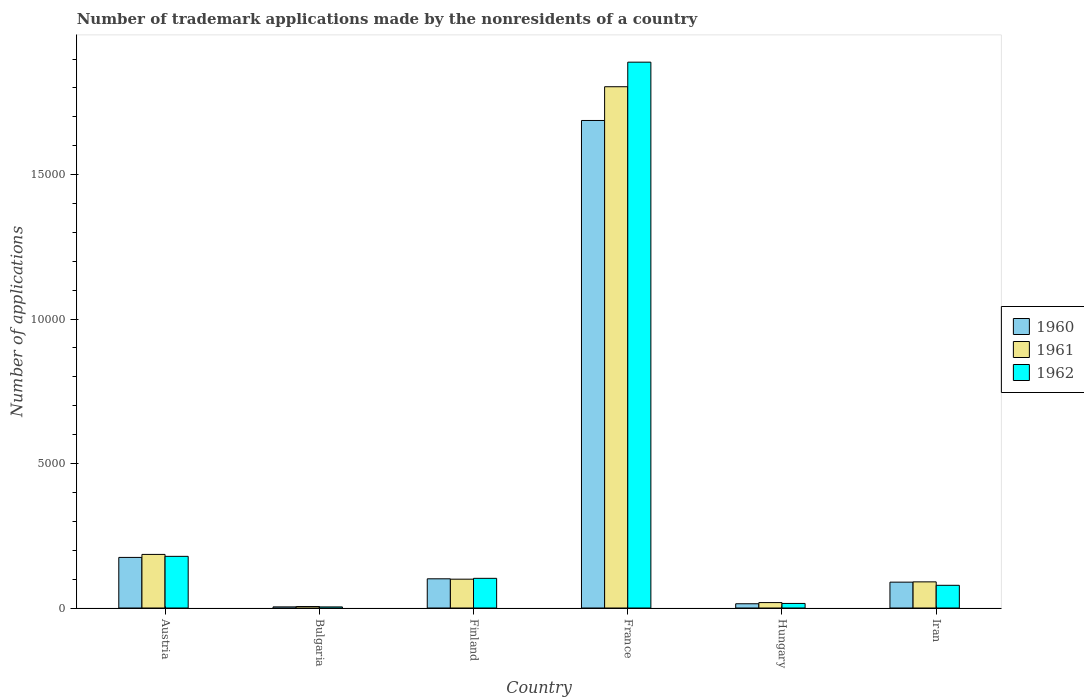How many groups of bars are there?
Offer a terse response. 6. Are the number of bars per tick equal to the number of legend labels?
Give a very brief answer. Yes. Are the number of bars on each tick of the X-axis equal?
Offer a terse response. Yes. What is the label of the 6th group of bars from the left?
Make the answer very short. Iran. In how many cases, is the number of bars for a given country not equal to the number of legend labels?
Offer a terse response. 0. What is the number of trademark applications made by the nonresidents in 1962 in Hungary?
Make the answer very short. 158. Across all countries, what is the maximum number of trademark applications made by the nonresidents in 1961?
Give a very brief answer. 1.80e+04. Across all countries, what is the minimum number of trademark applications made by the nonresidents in 1962?
Provide a short and direct response. 38. What is the total number of trademark applications made by the nonresidents in 1961 in the graph?
Your answer should be compact. 2.20e+04. What is the difference between the number of trademark applications made by the nonresidents in 1962 in Austria and that in France?
Offer a very short reply. -1.71e+04. What is the difference between the number of trademark applications made by the nonresidents in 1962 in Iran and the number of trademark applications made by the nonresidents in 1961 in Austria?
Give a very brief answer. -1069. What is the average number of trademark applications made by the nonresidents in 1960 per country?
Give a very brief answer. 3452.83. What is the difference between the number of trademark applications made by the nonresidents of/in 1961 and number of trademark applications made by the nonresidents of/in 1962 in Hungary?
Offer a terse response. 30. In how many countries, is the number of trademark applications made by the nonresidents in 1960 greater than 18000?
Provide a short and direct response. 0. What is the ratio of the number of trademark applications made by the nonresidents in 1962 in Austria to that in Finland?
Your response must be concise. 1.74. Is the number of trademark applications made by the nonresidents in 1961 in Finland less than that in France?
Give a very brief answer. Yes. Is the difference between the number of trademark applications made by the nonresidents in 1961 in Austria and Bulgaria greater than the difference between the number of trademark applications made by the nonresidents in 1962 in Austria and Bulgaria?
Give a very brief answer. Yes. What is the difference between the highest and the second highest number of trademark applications made by the nonresidents in 1960?
Offer a very short reply. 1.59e+04. What is the difference between the highest and the lowest number of trademark applications made by the nonresidents in 1961?
Keep it short and to the point. 1.80e+04. What does the 2nd bar from the left in Iran represents?
Give a very brief answer. 1961. What does the 2nd bar from the right in Finland represents?
Keep it short and to the point. 1961. Is it the case that in every country, the sum of the number of trademark applications made by the nonresidents in 1961 and number of trademark applications made by the nonresidents in 1960 is greater than the number of trademark applications made by the nonresidents in 1962?
Keep it short and to the point. Yes. Are the values on the major ticks of Y-axis written in scientific E-notation?
Ensure brevity in your answer.  No. Does the graph contain grids?
Provide a short and direct response. No. Where does the legend appear in the graph?
Ensure brevity in your answer.  Center right. How are the legend labels stacked?
Keep it short and to the point. Vertical. What is the title of the graph?
Make the answer very short. Number of trademark applications made by the nonresidents of a country. Does "1962" appear as one of the legend labels in the graph?
Your response must be concise. Yes. What is the label or title of the X-axis?
Make the answer very short. Country. What is the label or title of the Y-axis?
Offer a terse response. Number of applications. What is the Number of applications of 1960 in Austria?
Offer a very short reply. 1751. What is the Number of applications in 1961 in Austria?
Ensure brevity in your answer.  1855. What is the Number of applications of 1962 in Austria?
Give a very brief answer. 1788. What is the Number of applications of 1960 in Finland?
Ensure brevity in your answer.  1011. What is the Number of applications in 1961 in Finland?
Offer a very short reply. 998. What is the Number of applications of 1962 in Finland?
Provide a succinct answer. 1027. What is the Number of applications of 1960 in France?
Offer a terse response. 1.69e+04. What is the Number of applications in 1961 in France?
Ensure brevity in your answer.  1.80e+04. What is the Number of applications of 1962 in France?
Offer a very short reply. 1.89e+04. What is the Number of applications of 1960 in Hungary?
Offer a very short reply. 147. What is the Number of applications of 1961 in Hungary?
Your answer should be very brief. 188. What is the Number of applications in 1962 in Hungary?
Your response must be concise. 158. What is the Number of applications in 1960 in Iran?
Offer a very short reply. 895. What is the Number of applications in 1961 in Iran?
Make the answer very short. 905. What is the Number of applications in 1962 in Iran?
Your answer should be very brief. 786. Across all countries, what is the maximum Number of applications of 1960?
Make the answer very short. 1.69e+04. Across all countries, what is the maximum Number of applications in 1961?
Give a very brief answer. 1.80e+04. Across all countries, what is the maximum Number of applications of 1962?
Your answer should be very brief. 1.89e+04. Across all countries, what is the minimum Number of applications of 1960?
Make the answer very short. 39. Across all countries, what is the minimum Number of applications of 1961?
Your response must be concise. 51. Across all countries, what is the minimum Number of applications in 1962?
Offer a very short reply. 38. What is the total Number of applications in 1960 in the graph?
Keep it short and to the point. 2.07e+04. What is the total Number of applications of 1961 in the graph?
Offer a very short reply. 2.20e+04. What is the total Number of applications of 1962 in the graph?
Your answer should be compact. 2.27e+04. What is the difference between the Number of applications in 1960 in Austria and that in Bulgaria?
Your answer should be compact. 1712. What is the difference between the Number of applications of 1961 in Austria and that in Bulgaria?
Provide a short and direct response. 1804. What is the difference between the Number of applications of 1962 in Austria and that in Bulgaria?
Your answer should be compact. 1750. What is the difference between the Number of applications in 1960 in Austria and that in Finland?
Make the answer very short. 740. What is the difference between the Number of applications in 1961 in Austria and that in Finland?
Your answer should be compact. 857. What is the difference between the Number of applications in 1962 in Austria and that in Finland?
Provide a succinct answer. 761. What is the difference between the Number of applications of 1960 in Austria and that in France?
Ensure brevity in your answer.  -1.51e+04. What is the difference between the Number of applications in 1961 in Austria and that in France?
Give a very brief answer. -1.62e+04. What is the difference between the Number of applications of 1962 in Austria and that in France?
Provide a short and direct response. -1.71e+04. What is the difference between the Number of applications in 1960 in Austria and that in Hungary?
Ensure brevity in your answer.  1604. What is the difference between the Number of applications in 1961 in Austria and that in Hungary?
Provide a short and direct response. 1667. What is the difference between the Number of applications of 1962 in Austria and that in Hungary?
Give a very brief answer. 1630. What is the difference between the Number of applications in 1960 in Austria and that in Iran?
Make the answer very short. 856. What is the difference between the Number of applications of 1961 in Austria and that in Iran?
Provide a succinct answer. 950. What is the difference between the Number of applications of 1962 in Austria and that in Iran?
Keep it short and to the point. 1002. What is the difference between the Number of applications of 1960 in Bulgaria and that in Finland?
Your response must be concise. -972. What is the difference between the Number of applications of 1961 in Bulgaria and that in Finland?
Your answer should be very brief. -947. What is the difference between the Number of applications of 1962 in Bulgaria and that in Finland?
Provide a succinct answer. -989. What is the difference between the Number of applications of 1960 in Bulgaria and that in France?
Your answer should be very brief. -1.68e+04. What is the difference between the Number of applications of 1961 in Bulgaria and that in France?
Your answer should be very brief. -1.80e+04. What is the difference between the Number of applications of 1962 in Bulgaria and that in France?
Your answer should be compact. -1.89e+04. What is the difference between the Number of applications of 1960 in Bulgaria and that in Hungary?
Provide a short and direct response. -108. What is the difference between the Number of applications of 1961 in Bulgaria and that in Hungary?
Ensure brevity in your answer.  -137. What is the difference between the Number of applications of 1962 in Bulgaria and that in Hungary?
Keep it short and to the point. -120. What is the difference between the Number of applications of 1960 in Bulgaria and that in Iran?
Provide a succinct answer. -856. What is the difference between the Number of applications in 1961 in Bulgaria and that in Iran?
Keep it short and to the point. -854. What is the difference between the Number of applications of 1962 in Bulgaria and that in Iran?
Give a very brief answer. -748. What is the difference between the Number of applications in 1960 in Finland and that in France?
Your answer should be compact. -1.59e+04. What is the difference between the Number of applications of 1961 in Finland and that in France?
Your answer should be very brief. -1.70e+04. What is the difference between the Number of applications in 1962 in Finland and that in France?
Offer a very short reply. -1.79e+04. What is the difference between the Number of applications of 1960 in Finland and that in Hungary?
Keep it short and to the point. 864. What is the difference between the Number of applications in 1961 in Finland and that in Hungary?
Your response must be concise. 810. What is the difference between the Number of applications in 1962 in Finland and that in Hungary?
Offer a very short reply. 869. What is the difference between the Number of applications in 1960 in Finland and that in Iran?
Your response must be concise. 116. What is the difference between the Number of applications in 1961 in Finland and that in Iran?
Keep it short and to the point. 93. What is the difference between the Number of applications of 1962 in Finland and that in Iran?
Your answer should be very brief. 241. What is the difference between the Number of applications of 1960 in France and that in Hungary?
Your response must be concise. 1.67e+04. What is the difference between the Number of applications in 1961 in France and that in Hungary?
Provide a short and direct response. 1.79e+04. What is the difference between the Number of applications in 1962 in France and that in Hungary?
Your answer should be very brief. 1.87e+04. What is the difference between the Number of applications of 1960 in France and that in Iran?
Offer a very short reply. 1.60e+04. What is the difference between the Number of applications in 1961 in France and that in Iran?
Your response must be concise. 1.71e+04. What is the difference between the Number of applications of 1962 in France and that in Iran?
Provide a succinct answer. 1.81e+04. What is the difference between the Number of applications of 1960 in Hungary and that in Iran?
Your answer should be compact. -748. What is the difference between the Number of applications in 1961 in Hungary and that in Iran?
Keep it short and to the point. -717. What is the difference between the Number of applications in 1962 in Hungary and that in Iran?
Ensure brevity in your answer.  -628. What is the difference between the Number of applications in 1960 in Austria and the Number of applications in 1961 in Bulgaria?
Keep it short and to the point. 1700. What is the difference between the Number of applications in 1960 in Austria and the Number of applications in 1962 in Bulgaria?
Keep it short and to the point. 1713. What is the difference between the Number of applications of 1961 in Austria and the Number of applications of 1962 in Bulgaria?
Your response must be concise. 1817. What is the difference between the Number of applications of 1960 in Austria and the Number of applications of 1961 in Finland?
Make the answer very short. 753. What is the difference between the Number of applications of 1960 in Austria and the Number of applications of 1962 in Finland?
Your answer should be compact. 724. What is the difference between the Number of applications of 1961 in Austria and the Number of applications of 1962 in Finland?
Give a very brief answer. 828. What is the difference between the Number of applications in 1960 in Austria and the Number of applications in 1961 in France?
Offer a terse response. -1.63e+04. What is the difference between the Number of applications of 1960 in Austria and the Number of applications of 1962 in France?
Make the answer very short. -1.71e+04. What is the difference between the Number of applications of 1961 in Austria and the Number of applications of 1962 in France?
Offer a very short reply. -1.70e+04. What is the difference between the Number of applications in 1960 in Austria and the Number of applications in 1961 in Hungary?
Your response must be concise. 1563. What is the difference between the Number of applications of 1960 in Austria and the Number of applications of 1962 in Hungary?
Provide a short and direct response. 1593. What is the difference between the Number of applications of 1961 in Austria and the Number of applications of 1962 in Hungary?
Make the answer very short. 1697. What is the difference between the Number of applications in 1960 in Austria and the Number of applications in 1961 in Iran?
Provide a short and direct response. 846. What is the difference between the Number of applications in 1960 in Austria and the Number of applications in 1962 in Iran?
Offer a very short reply. 965. What is the difference between the Number of applications in 1961 in Austria and the Number of applications in 1962 in Iran?
Provide a succinct answer. 1069. What is the difference between the Number of applications of 1960 in Bulgaria and the Number of applications of 1961 in Finland?
Ensure brevity in your answer.  -959. What is the difference between the Number of applications in 1960 in Bulgaria and the Number of applications in 1962 in Finland?
Your answer should be compact. -988. What is the difference between the Number of applications in 1961 in Bulgaria and the Number of applications in 1962 in Finland?
Offer a very short reply. -976. What is the difference between the Number of applications of 1960 in Bulgaria and the Number of applications of 1961 in France?
Offer a terse response. -1.80e+04. What is the difference between the Number of applications in 1960 in Bulgaria and the Number of applications in 1962 in France?
Provide a succinct answer. -1.89e+04. What is the difference between the Number of applications in 1961 in Bulgaria and the Number of applications in 1962 in France?
Your response must be concise. -1.88e+04. What is the difference between the Number of applications in 1960 in Bulgaria and the Number of applications in 1961 in Hungary?
Keep it short and to the point. -149. What is the difference between the Number of applications in 1960 in Bulgaria and the Number of applications in 1962 in Hungary?
Provide a succinct answer. -119. What is the difference between the Number of applications of 1961 in Bulgaria and the Number of applications of 1962 in Hungary?
Your response must be concise. -107. What is the difference between the Number of applications in 1960 in Bulgaria and the Number of applications in 1961 in Iran?
Your answer should be compact. -866. What is the difference between the Number of applications in 1960 in Bulgaria and the Number of applications in 1962 in Iran?
Provide a succinct answer. -747. What is the difference between the Number of applications of 1961 in Bulgaria and the Number of applications of 1962 in Iran?
Offer a very short reply. -735. What is the difference between the Number of applications of 1960 in Finland and the Number of applications of 1961 in France?
Keep it short and to the point. -1.70e+04. What is the difference between the Number of applications of 1960 in Finland and the Number of applications of 1962 in France?
Keep it short and to the point. -1.79e+04. What is the difference between the Number of applications in 1961 in Finland and the Number of applications in 1962 in France?
Offer a very short reply. -1.79e+04. What is the difference between the Number of applications of 1960 in Finland and the Number of applications of 1961 in Hungary?
Your response must be concise. 823. What is the difference between the Number of applications in 1960 in Finland and the Number of applications in 1962 in Hungary?
Your response must be concise. 853. What is the difference between the Number of applications of 1961 in Finland and the Number of applications of 1962 in Hungary?
Keep it short and to the point. 840. What is the difference between the Number of applications of 1960 in Finland and the Number of applications of 1961 in Iran?
Provide a short and direct response. 106. What is the difference between the Number of applications in 1960 in Finland and the Number of applications in 1962 in Iran?
Provide a succinct answer. 225. What is the difference between the Number of applications of 1961 in Finland and the Number of applications of 1962 in Iran?
Give a very brief answer. 212. What is the difference between the Number of applications of 1960 in France and the Number of applications of 1961 in Hungary?
Provide a succinct answer. 1.67e+04. What is the difference between the Number of applications of 1960 in France and the Number of applications of 1962 in Hungary?
Make the answer very short. 1.67e+04. What is the difference between the Number of applications of 1961 in France and the Number of applications of 1962 in Hungary?
Offer a terse response. 1.79e+04. What is the difference between the Number of applications of 1960 in France and the Number of applications of 1961 in Iran?
Your answer should be compact. 1.60e+04. What is the difference between the Number of applications of 1960 in France and the Number of applications of 1962 in Iran?
Ensure brevity in your answer.  1.61e+04. What is the difference between the Number of applications in 1961 in France and the Number of applications in 1962 in Iran?
Ensure brevity in your answer.  1.73e+04. What is the difference between the Number of applications of 1960 in Hungary and the Number of applications of 1961 in Iran?
Give a very brief answer. -758. What is the difference between the Number of applications in 1960 in Hungary and the Number of applications in 1962 in Iran?
Provide a succinct answer. -639. What is the difference between the Number of applications of 1961 in Hungary and the Number of applications of 1962 in Iran?
Your response must be concise. -598. What is the average Number of applications of 1960 per country?
Provide a short and direct response. 3452.83. What is the average Number of applications in 1961 per country?
Keep it short and to the point. 3673.17. What is the average Number of applications in 1962 per country?
Your answer should be compact. 3781.5. What is the difference between the Number of applications of 1960 and Number of applications of 1961 in Austria?
Offer a terse response. -104. What is the difference between the Number of applications in 1960 and Number of applications in 1962 in Austria?
Your response must be concise. -37. What is the difference between the Number of applications of 1960 and Number of applications of 1962 in Bulgaria?
Offer a very short reply. 1. What is the difference between the Number of applications in 1960 and Number of applications in 1961 in France?
Keep it short and to the point. -1168. What is the difference between the Number of applications of 1960 and Number of applications of 1962 in France?
Provide a short and direct response. -2018. What is the difference between the Number of applications of 1961 and Number of applications of 1962 in France?
Ensure brevity in your answer.  -850. What is the difference between the Number of applications in 1960 and Number of applications in 1961 in Hungary?
Your answer should be very brief. -41. What is the difference between the Number of applications of 1961 and Number of applications of 1962 in Hungary?
Keep it short and to the point. 30. What is the difference between the Number of applications of 1960 and Number of applications of 1961 in Iran?
Provide a short and direct response. -10. What is the difference between the Number of applications in 1960 and Number of applications in 1962 in Iran?
Provide a succinct answer. 109. What is the difference between the Number of applications in 1961 and Number of applications in 1962 in Iran?
Give a very brief answer. 119. What is the ratio of the Number of applications of 1960 in Austria to that in Bulgaria?
Offer a terse response. 44.9. What is the ratio of the Number of applications of 1961 in Austria to that in Bulgaria?
Give a very brief answer. 36.37. What is the ratio of the Number of applications of 1962 in Austria to that in Bulgaria?
Your answer should be compact. 47.05. What is the ratio of the Number of applications of 1960 in Austria to that in Finland?
Offer a very short reply. 1.73. What is the ratio of the Number of applications in 1961 in Austria to that in Finland?
Keep it short and to the point. 1.86. What is the ratio of the Number of applications of 1962 in Austria to that in Finland?
Ensure brevity in your answer.  1.74. What is the ratio of the Number of applications in 1960 in Austria to that in France?
Provide a succinct answer. 0.1. What is the ratio of the Number of applications of 1961 in Austria to that in France?
Give a very brief answer. 0.1. What is the ratio of the Number of applications of 1962 in Austria to that in France?
Your answer should be compact. 0.09. What is the ratio of the Number of applications of 1960 in Austria to that in Hungary?
Make the answer very short. 11.91. What is the ratio of the Number of applications of 1961 in Austria to that in Hungary?
Ensure brevity in your answer.  9.87. What is the ratio of the Number of applications of 1962 in Austria to that in Hungary?
Give a very brief answer. 11.32. What is the ratio of the Number of applications in 1960 in Austria to that in Iran?
Make the answer very short. 1.96. What is the ratio of the Number of applications in 1961 in Austria to that in Iran?
Your response must be concise. 2.05. What is the ratio of the Number of applications in 1962 in Austria to that in Iran?
Your answer should be very brief. 2.27. What is the ratio of the Number of applications of 1960 in Bulgaria to that in Finland?
Provide a succinct answer. 0.04. What is the ratio of the Number of applications in 1961 in Bulgaria to that in Finland?
Offer a very short reply. 0.05. What is the ratio of the Number of applications of 1962 in Bulgaria to that in Finland?
Keep it short and to the point. 0.04. What is the ratio of the Number of applications of 1960 in Bulgaria to that in France?
Offer a terse response. 0. What is the ratio of the Number of applications of 1961 in Bulgaria to that in France?
Keep it short and to the point. 0. What is the ratio of the Number of applications of 1962 in Bulgaria to that in France?
Keep it short and to the point. 0. What is the ratio of the Number of applications of 1960 in Bulgaria to that in Hungary?
Ensure brevity in your answer.  0.27. What is the ratio of the Number of applications in 1961 in Bulgaria to that in Hungary?
Give a very brief answer. 0.27. What is the ratio of the Number of applications in 1962 in Bulgaria to that in Hungary?
Your answer should be very brief. 0.24. What is the ratio of the Number of applications in 1960 in Bulgaria to that in Iran?
Ensure brevity in your answer.  0.04. What is the ratio of the Number of applications of 1961 in Bulgaria to that in Iran?
Provide a short and direct response. 0.06. What is the ratio of the Number of applications in 1962 in Bulgaria to that in Iran?
Your answer should be very brief. 0.05. What is the ratio of the Number of applications of 1960 in Finland to that in France?
Your answer should be very brief. 0.06. What is the ratio of the Number of applications of 1961 in Finland to that in France?
Give a very brief answer. 0.06. What is the ratio of the Number of applications of 1962 in Finland to that in France?
Provide a succinct answer. 0.05. What is the ratio of the Number of applications in 1960 in Finland to that in Hungary?
Give a very brief answer. 6.88. What is the ratio of the Number of applications in 1961 in Finland to that in Hungary?
Offer a very short reply. 5.31. What is the ratio of the Number of applications of 1960 in Finland to that in Iran?
Ensure brevity in your answer.  1.13. What is the ratio of the Number of applications of 1961 in Finland to that in Iran?
Make the answer very short. 1.1. What is the ratio of the Number of applications of 1962 in Finland to that in Iran?
Keep it short and to the point. 1.31. What is the ratio of the Number of applications of 1960 in France to that in Hungary?
Make the answer very short. 114.79. What is the ratio of the Number of applications of 1961 in France to that in Hungary?
Make the answer very short. 95.97. What is the ratio of the Number of applications in 1962 in France to that in Hungary?
Offer a terse response. 119.57. What is the ratio of the Number of applications of 1960 in France to that in Iran?
Your answer should be compact. 18.85. What is the ratio of the Number of applications of 1961 in France to that in Iran?
Your response must be concise. 19.94. What is the ratio of the Number of applications in 1962 in France to that in Iran?
Give a very brief answer. 24.04. What is the ratio of the Number of applications of 1960 in Hungary to that in Iran?
Your answer should be compact. 0.16. What is the ratio of the Number of applications in 1961 in Hungary to that in Iran?
Offer a very short reply. 0.21. What is the ratio of the Number of applications of 1962 in Hungary to that in Iran?
Keep it short and to the point. 0.2. What is the difference between the highest and the second highest Number of applications of 1960?
Provide a succinct answer. 1.51e+04. What is the difference between the highest and the second highest Number of applications in 1961?
Make the answer very short. 1.62e+04. What is the difference between the highest and the second highest Number of applications in 1962?
Keep it short and to the point. 1.71e+04. What is the difference between the highest and the lowest Number of applications of 1960?
Keep it short and to the point. 1.68e+04. What is the difference between the highest and the lowest Number of applications of 1961?
Give a very brief answer. 1.80e+04. What is the difference between the highest and the lowest Number of applications in 1962?
Your answer should be very brief. 1.89e+04. 